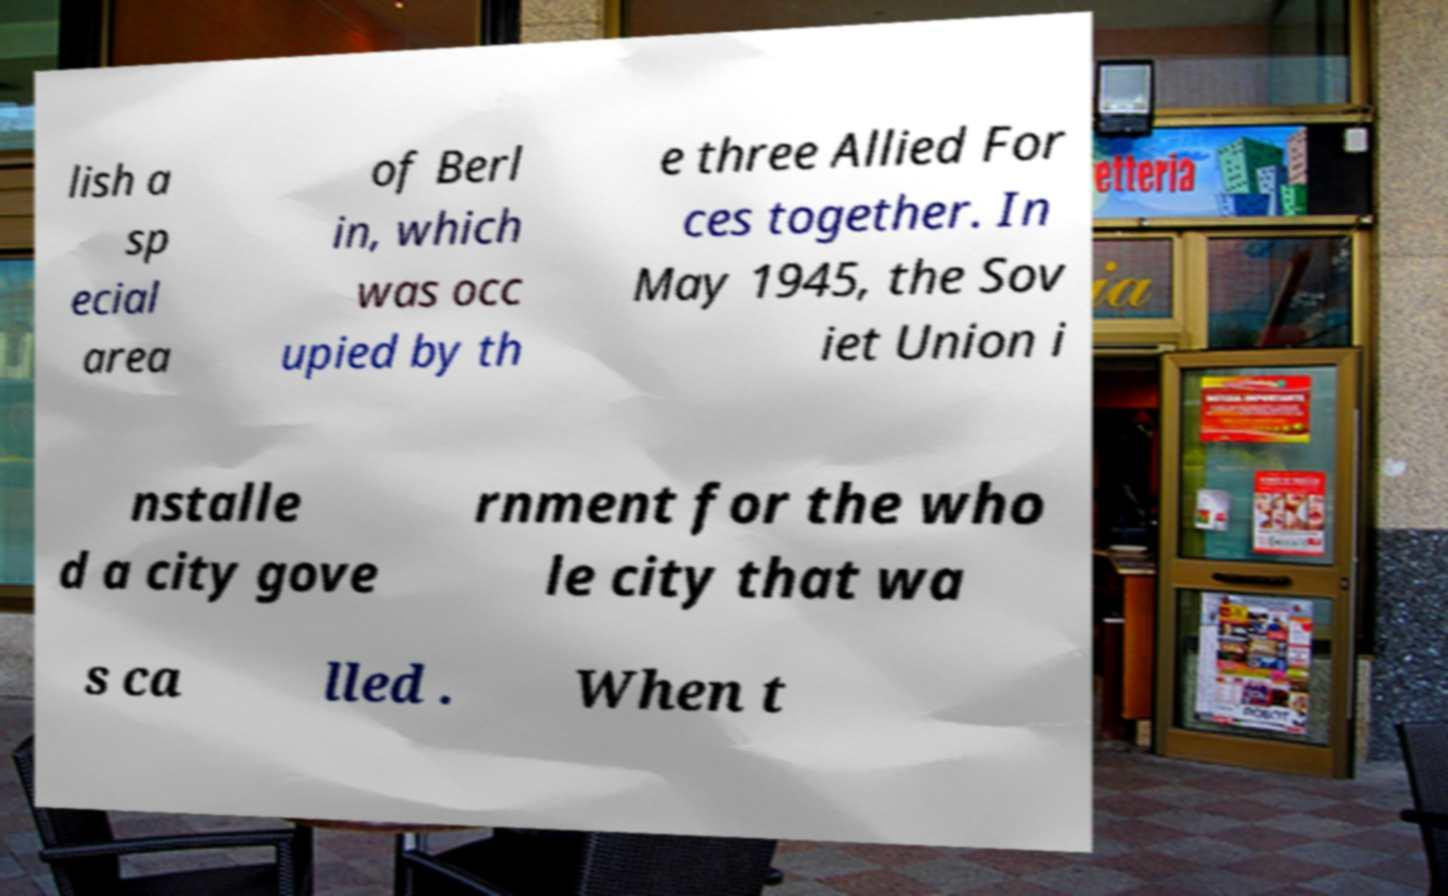Could you extract and type out the text from this image? lish a sp ecial area of Berl in, which was occ upied by th e three Allied For ces together. In May 1945, the Sov iet Union i nstalle d a city gove rnment for the who le city that wa s ca lled . When t 